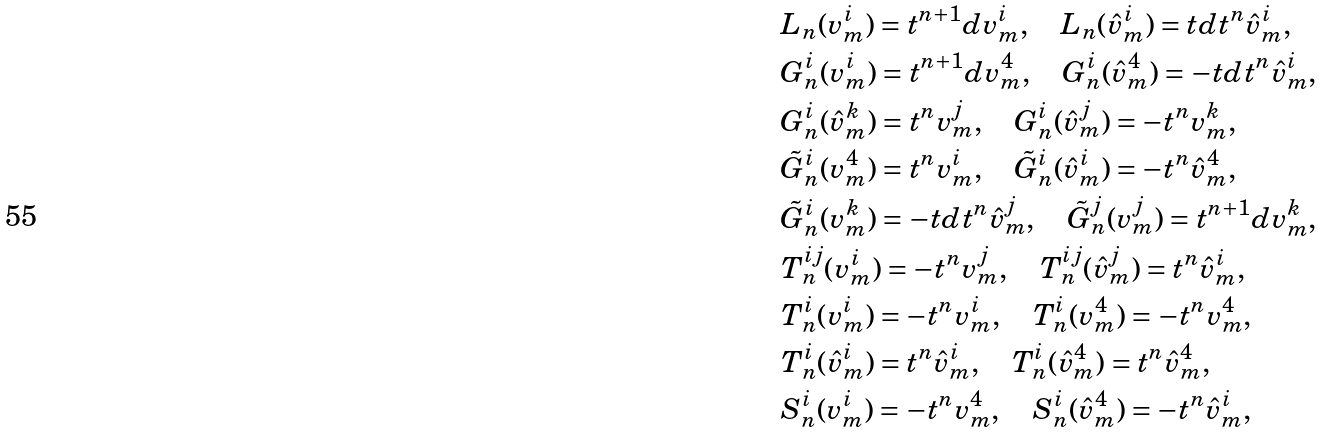<formula> <loc_0><loc_0><loc_500><loc_500>& L _ { n } ( v _ { m } ^ { i } ) = t ^ { n + 1 } d v _ { m } ^ { i } , \quad L _ { n } ( \hat { v } _ { m } ^ { i } ) = t d t ^ { n } \hat { v } _ { m } ^ { i } , \\ & G _ { n } ^ { i } ( v _ { m } ^ { i } ) = t ^ { n + 1 } d v _ { m } ^ { 4 } , \quad G _ { n } ^ { i } ( \hat { v } _ { m } ^ { 4 } ) = - t d t ^ { n } \hat { v } _ { m } ^ { i } , \\ & G _ { n } ^ { i } ( \hat { v } _ { m } ^ { k } ) = t ^ { n } { v } _ { m } ^ { j } , \quad G _ { n } ^ { i } ( \hat { v } _ { m } ^ { j } ) = - t ^ { n } { v } _ { m } ^ { k } , \\ & \tilde { G } _ { n } ^ { i } ( v _ { m } ^ { 4 } ) = t ^ { n } v _ { m } ^ { i } , \quad \tilde { G } _ { n } ^ { i } ( \hat { v } _ { m } ^ { i } ) = - t ^ { n } \hat { v } _ { m } ^ { 4 } , \\ & \tilde { G } _ { n } ^ { i } ( { v } _ { m } ^ { k } ) = - t d t ^ { n } \hat { v } _ { m } ^ { j } , \quad \tilde { G } _ { n } ^ { j } ( { v } _ { m } ^ { j } ) = t ^ { n + 1 } d v _ { m } ^ { k } , \\ & T _ { n } ^ { i j } ( v _ { m } ^ { i } ) = - t ^ { n } v _ { m } ^ { j } , \quad T _ { n } ^ { i j } ( \hat { v } _ { m } ^ { j } ) = t ^ { n } \hat { v } _ { m } ^ { i } , \\ & T _ { n } ^ { i } ( v _ { m } ^ { i } ) = - t ^ { n } v _ { m } ^ { i } , \quad T _ { n } ^ { i } ( v _ { m } ^ { 4 } ) = - t ^ { n } v _ { m } ^ { 4 } , \\ & T _ { n } ^ { i } ( \hat { v } _ { m } ^ { i } ) = t ^ { n } \hat { v } _ { m } ^ { i } , \quad T _ { n } ^ { i } ( \hat { v } _ { m } ^ { 4 } ) = t ^ { n } \hat { v } _ { m } ^ { 4 } , \\ & S _ { n } ^ { i } ( v _ { m } ^ { i } ) = - t ^ { n } v _ { m } ^ { 4 } , \quad S _ { n } ^ { i } ( \hat { v } _ { m } ^ { 4 } ) = - t ^ { n } \hat { v } _ { m } ^ { i } , \\</formula> 